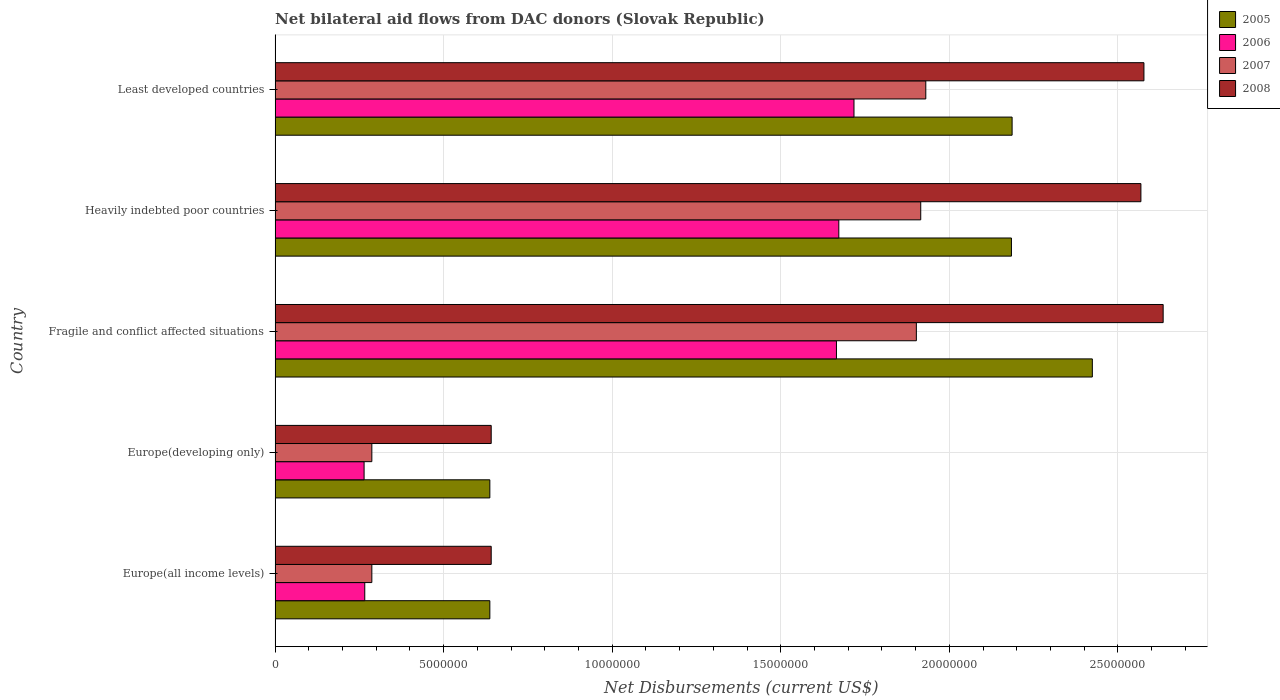Are the number of bars on each tick of the Y-axis equal?
Give a very brief answer. Yes. How many bars are there on the 4th tick from the bottom?
Provide a short and direct response. 4. What is the label of the 1st group of bars from the top?
Keep it short and to the point. Least developed countries. In how many cases, is the number of bars for a given country not equal to the number of legend labels?
Offer a terse response. 0. What is the net bilateral aid flows in 2008 in Heavily indebted poor countries?
Your answer should be very brief. 2.57e+07. Across all countries, what is the maximum net bilateral aid flows in 2007?
Offer a terse response. 1.93e+07. Across all countries, what is the minimum net bilateral aid flows in 2005?
Make the answer very short. 6.37e+06. In which country was the net bilateral aid flows in 2007 maximum?
Your answer should be compact. Least developed countries. In which country was the net bilateral aid flows in 2005 minimum?
Make the answer very short. Europe(all income levels). What is the total net bilateral aid flows in 2005 in the graph?
Provide a short and direct response. 8.07e+07. What is the difference between the net bilateral aid flows in 2005 in Europe(all income levels) and that in Least developed countries?
Make the answer very short. -1.55e+07. What is the difference between the net bilateral aid flows in 2005 in Heavily indebted poor countries and the net bilateral aid flows in 2008 in Europe(all income levels)?
Your response must be concise. 1.54e+07. What is the average net bilateral aid flows in 2008 per country?
Your answer should be very brief. 1.81e+07. What is the difference between the net bilateral aid flows in 2007 and net bilateral aid flows in 2008 in Fragile and conflict affected situations?
Give a very brief answer. -7.32e+06. What is the ratio of the net bilateral aid flows in 2005 in Europe(developing only) to that in Least developed countries?
Provide a short and direct response. 0.29. Is the difference between the net bilateral aid flows in 2007 in Europe(developing only) and Heavily indebted poor countries greater than the difference between the net bilateral aid flows in 2008 in Europe(developing only) and Heavily indebted poor countries?
Ensure brevity in your answer.  Yes. What is the difference between the highest and the lowest net bilateral aid flows in 2005?
Your answer should be very brief. 1.79e+07. What does the 3rd bar from the top in Europe(developing only) represents?
Ensure brevity in your answer.  2006. Are all the bars in the graph horizontal?
Your answer should be very brief. Yes. What is the difference between two consecutive major ticks on the X-axis?
Provide a succinct answer. 5.00e+06. Where does the legend appear in the graph?
Provide a short and direct response. Top right. How many legend labels are there?
Your answer should be compact. 4. How are the legend labels stacked?
Your answer should be compact. Vertical. What is the title of the graph?
Make the answer very short. Net bilateral aid flows from DAC donors (Slovak Republic). Does "2013" appear as one of the legend labels in the graph?
Your response must be concise. No. What is the label or title of the X-axis?
Offer a very short reply. Net Disbursements (current US$). What is the label or title of the Y-axis?
Your answer should be compact. Country. What is the Net Disbursements (current US$) of 2005 in Europe(all income levels)?
Give a very brief answer. 6.37e+06. What is the Net Disbursements (current US$) of 2006 in Europe(all income levels)?
Ensure brevity in your answer.  2.66e+06. What is the Net Disbursements (current US$) in 2007 in Europe(all income levels)?
Provide a succinct answer. 2.87e+06. What is the Net Disbursements (current US$) in 2008 in Europe(all income levels)?
Provide a short and direct response. 6.41e+06. What is the Net Disbursements (current US$) in 2005 in Europe(developing only)?
Provide a succinct answer. 6.37e+06. What is the Net Disbursements (current US$) of 2006 in Europe(developing only)?
Offer a terse response. 2.64e+06. What is the Net Disbursements (current US$) in 2007 in Europe(developing only)?
Keep it short and to the point. 2.87e+06. What is the Net Disbursements (current US$) of 2008 in Europe(developing only)?
Your response must be concise. 6.41e+06. What is the Net Disbursements (current US$) of 2005 in Fragile and conflict affected situations?
Offer a terse response. 2.42e+07. What is the Net Disbursements (current US$) in 2006 in Fragile and conflict affected situations?
Your answer should be compact. 1.66e+07. What is the Net Disbursements (current US$) of 2007 in Fragile and conflict affected situations?
Provide a succinct answer. 1.90e+07. What is the Net Disbursements (current US$) of 2008 in Fragile and conflict affected situations?
Provide a succinct answer. 2.63e+07. What is the Net Disbursements (current US$) of 2005 in Heavily indebted poor countries?
Give a very brief answer. 2.18e+07. What is the Net Disbursements (current US$) of 2006 in Heavily indebted poor countries?
Your response must be concise. 1.67e+07. What is the Net Disbursements (current US$) of 2007 in Heavily indebted poor countries?
Offer a very short reply. 1.92e+07. What is the Net Disbursements (current US$) in 2008 in Heavily indebted poor countries?
Give a very brief answer. 2.57e+07. What is the Net Disbursements (current US$) of 2005 in Least developed countries?
Make the answer very short. 2.19e+07. What is the Net Disbursements (current US$) of 2006 in Least developed countries?
Your answer should be compact. 1.72e+07. What is the Net Disbursements (current US$) of 2007 in Least developed countries?
Give a very brief answer. 1.93e+07. What is the Net Disbursements (current US$) of 2008 in Least developed countries?
Your answer should be very brief. 2.58e+07. Across all countries, what is the maximum Net Disbursements (current US$) in 2005?
Ensure brevity in your answer.  2.42e+07. Across all countries, what is the maximum Net Disbursements (current US$) in 2006?
Provide a succinct answer. 1.72e+07. Across all countries, what is the maximum Net Disbursements (current US$) in 2007?
Give a very brief answer. 1.93e+07. Across all countries, what is the maximum Net Disbursements (current US$) in 2008?
Give a very brief answer. 2.63e+07. Across all countries, what is the minimum Net Disbursements (current US$) in 2005?
Your response must be concise. 6.37e+06. Across all countries, what is the minimum Net Disbursements (current US$) of 2006?
Provide a short and direct response. 2.64e+06. Across all countries, what is the minimum Net Disbursements (current US$) in 2007?
Your response must be concise. 2.87e+06. Across all countries, what is the minimum Net Disbursements (current US$) of 2008?
Offer a very short reply. 6.41e+06. What is the total Net Disbursements (current US$) in 2005 in the graph?
Ensure brevity in your answer.  8.07e+07. What is the total Net Disbursements (current US$) in 2006 in the graph?
Keep it short and to the point. 5.58e+07. What is the total Net Disbursements (current US$) of 2007 in the graph?
Your answer should be compact. 6.32e+07. What is the total Net Disbursements (current US$) in 2008 in the graph?
Offer a terse response. 9.06e+07. What is the difference between the Net Disbursements (current US$) of 2005 in Europe(all income levels) and that in Europe(developing only)?
Give a very brief answer. 0. What is the difference between the Net Disbursements (current US$) in 2007 in Europe(all income levels) and that in Europe(developing only)?
Provide a short and direct response. 0. What is the difference between the Net Disbursements (current US$) in 2005 in Europe(all income levels) and that in Fragile and conflict affected situations?
Provide a succinct answer. -1.79e+07. What is the difference between the Net Disbursements (current US$) of 2006 in Europe(all income levels) and that in Fragile and conflict affected situations?
Your answer should be very brief. -1.40e+07. What is the difference between the Net Disbursements (current US$) of 2007 in Europe(all income levels) and that in Fragile and conflict affected situations?
Your answer should be very brief. -1.62e+07. What is the difference between the Net Disbursements (current US$) of 2008 in Europe(all income levels) and that in Fragile and conflict affected situations?
Ensure brevity in your answer.  -1.99e+07. What is the difference between the Net Disbursements (current US$) in 2005 in Europe(all income levels) and that in Heavily indebted poor countries?
Your answer should be compact. -1.55e+07. What is the difference between the Net Disbursements (current US$) in 2006 in Europe(all income levels) and that in Heavily indebted poor countries?
Make the answer very short. -1.41e+07. What is the difference between the Net Disbursements (current US$) in 2007 in Europe(all income levels) and that in Heavily indebted poor countries?
Keep it short and to the point. -1.63e+07. What is the difference between the Net Disbursements (current US$) in 2008 in Europe(all income levels) and that in Heavily indebted poor countries?
Offer a very short reply. -1.93e+07. What is the difference between the Net Disbursements (current US$) of 2005 in Europe(all income levels) and that in Least developed countries?
Keep it short and to the point. -1.55e+07. What is the difference between the Net Disbursements (current US$) of 2006 in Europe(all income levels) and that in Least developed countries?
Keep it short and to the point. -1.45e+07. What is the difference between the Net Disbursements (current US$) in 2007 in Europe(all income levels) and that in Least developed countries?
Your answer should be very brief. -1.64e+07. What is the difference between the Net Disbursements (current US$) in 2008 in Europe(all income levels) and that in Least developed countries?
Provide a succinct answer. -1.94e+07. What is the difference between the Net Disbursements (current US$) of 2005 in Europe(developing only) and that in Fragile and conflict affected situations?
Make the answer very short. -1.79e+07. What is the difference between the Net Disbursements (current US$) of 2006 in Europe(developing only) and that in Fragile and conflict affected situations?
Ensure brevity in your answer.  -1.40e+07. What is the difference between the Net Disbursements (current US$) of 2007 in Europe(developing only) and that in Fragile and conflict affected situations?
Make the answer very short. -1.62e+07. What is the difference between the Net Disbursements (current US$) of 2008 in Europe(developing only) and that in Fragile and conflict affected situations?
Provide a short and direct response. -1.99e+07. What is the difference between the Net Disbursements (current US$) of 2005 in Europe(developing only) and that in Heavily indebted poor countries?
Your answer should be very brief. -1.55e+07. What is the difference between the Net Disbursements (current US$) in 2006 in Europe(developing only) and that in Heavily indebted poor countries?
Make the answer very short. -1.41e+07. What is the difference between the Net Disbursements (current US$) of 2007 in Europe(developing only) and that in Heavily indebted poor countries?
Your response must be concise. -1.63e+07. What is the difference between the Net Disbursements (current US$) of 2008 in Europe(developing only) and that in Heavily indebted poor countries?
Give a very brief answer. -1.93e+07. What is the difference between the Net Disbursements (current US$) in 2005 in Europe(developing only) and that in Least developed countries?
Give a very brief answer. -1.55e+07. What is the difference between the Net Disbursements (current US$) in 2006 in Europe(developing only) and that in Least developed countries?
Make the answer very short. -1.45e+07. What is the difference between the Net Disbursements (current US$) of 2007 in Europe(developing only) and that in Least developed countries?
Provide a short and direct response. -1.64e+07. What is the difference between the Net Disbursements (current US$) in 2008 in Europe(developing only) and that in Least developed countries?
Ensure brevity in your answer.  -1.94e+07. What is the difference between the Net Disbursements (current US$) in 2005 in Fragile and conflict affected situations and that in Heavily indebted poor countries?
Ensure brevity in your answer.  2.40e+06. What is the difference between the Net Disbursements (current US$) in 2006 in Fragile and conflict affected situations and that in Heavily indebted poor countries?
Offer a terse response. -7.00e+04. What is the difference between the Net Disbursements (current US$) in 2007 in Fragile and conflict affected situations and that in Heavily indebted poor countries?
Your answer should be compact. -1.30e+05. What is the difference between the Net Disbursements (current US$) of 2005 in Fragile and conflict affected situations and that in Least developed countries?
Offer a very short reply. 2.38e+06. What is the difference between the Net Disbursements (current US$) of 2006 in Fragile and conflict affected situations and that in Least developed countries?
Offer a terse response. -5.20e+05. What is the difference between the Net Disbursements (current US$) of 2007 in Fragile and conflict affected situations and that in Least developed countries?
Offer a terse response. -2.80e+05. What is the difference between the Net Disbursements (current US$) of 2008 in Fragile and conflict affected situations and that in Least developed countries?
Your answer should be very brief. 5.70e+05. What is the difference between the Net Disbursements (current US$) in 2005 in Heavily indebted poor countries and that in Least developed countries?
Your answer should be very brief. -2.00e+04. What is the difference between the Net Disbursements (current US$) in 2006 in Heavily indebted poor countries and that in Least developed countries?
Your response must be concise. -4.50e+05. What is the difference between the Net Disbursements (current US$) in 2008 in Heavily indebted poor countries and that in Least developed countries?
Your response must be concise. -9.00e+04. What is the difference between the Net Disbursements (current US$) of 2005 in Europe(all income levels) and the Net Disbursements (current US$) of 2006 in Europe(developing only)?
Your answer should be very brief. 3.73e+06. What is the difference between the Net Disbursements (current US$) in 2005 in Europe(all income levels) and the Net Disbursements (current US$) in 2007 in Europe(developing only)?
Give a very brief answer. 3.50e+06. What is the difference between the Net Disbursements (current US$) in 2006 in Europe(all income levels) and the Net Disbursements (current US$) in 2008 in Europe(developing only)?
Offer a very short reply. -3.75e+06. What is the difference between the Net Disbursements (current US$) in 2007 in Europe(all income levels) and the Net Disbursements (current US$) in 2008 in Europe(developing only)?
Your answer should be very brief. -3.54e+06. What is the difference between the Net Disbursements (current US$) of 2005 in Europe(all income levels) and the Net Disbursements (current US$) of 2006 in Fragile and conflict affected situations?
Offer a terse response. -1.03e+07. What is the difference between the Net Disbursements (current US$) of 2005 in Europe(all income levels) and the Net Disbursements (current US$) of 2007 in Fragile and conflict affected situations?
Your answer should be compact. -1.26e+07. What is the difference between the Net Disbursements (current US$) in 2005 in Europe(all income levels) and the Net Disbursements (current US$) in 2008 in Fragile and conflict affected situations?
Provide a short and direct response. -2.00e+07. What is the difference between the Net Disbursements (current US$) of 2006 in Europe(all income levels) and the Net Disbursements (current US$) of 2007 in Fragile and conflict affected situations?
Your answer should be compact. -1.64e+07. What is the difference between the Net Disbursements (current US$) of 2006 in Europe(all income levels) and the Net Disbursements (current US$) of 2008 in Fragile and conflict affected situations?
Make the answer very short. -2.37e+07. What is the difference between the Net Disbursements (current US$) of 2007 in Europe(all income levels) and the Net Disbursements (current US$) of 2008 in Fragile and conflict affected situations?
Your response must be concise. -2.35e+07. What is the difference between the Net Disbursements (current US$) in 2005 in Europe(all income levels) and the Net Disbursements (current US$) in 2006 in Heavily indebted poor countries?
Your response must be concise. -1.04e+07. What is the difference between the Net Disbursements (current US$) in 2005 in Europe(all income levels) and the Net Disbursements (current US$) in 2007 in Heavily indebted poor countries?
Ensure brevity in your answer.  -1.28e+07. What is the difference between the Net Disbursements (current US$) of 2005 in Europe(all income levels) and the Net Disbursements (current US$) of 2008 in Heavily indebted poor countries?
Your response must be concise. -1.93e+07. What is the difference between the Net Disbursements (current US$) in 2006 in Europe(all income levels) and the Net Disbursements (current US$) in 2007 in Heavily indebted poor countries?
Your response must be concise. -1.65e+07. What is the difference between the Net Disbursements (current US$) in 2006 in Europe(all income levels) and the Net Disbursements (current US$) in 2008 in Heavily indebted poor countries?
Keep it short and to the point. -2.30e+07. What is the difference between the Net Disbursements (current US$) in 2007 in Europe(all income levels) and the Net Disbursements (current US$) in 2008 in Heavily indebted poor countries?
Offer a very short reply. -2.28e+07. What is the difference between the Net Disbursements (current US$) in 2005 in Europe(all income levels) and the Net Disbursements (current US$) in 2006 in Least developed countries?
Keep it short and to the point. -1.08e+07. What is the difference between the Net Disbursements (current US$) of 2005 in Europe(all income levels) and the Net Disbursements (current US$) of 2007 in Least developed countries?
Offer a terse response. -1.29e+07. What is the difference between the Net Disbursements (current US$) in 2005 in Europe(all income levels) and the Net Disbursements (current US$) in 2008 in Least developed countries?
Make the answer very short. -1.94e+07. What is the difference between the Net Disbursements (current US$) in 2006 in Europe(all income levels) and the Net Disbursements (current US$) in 2007 in Least developed countries?
Provide a short and direct response. -1.66e+07. What is the difference between the Net Disbursements (current US$) of 2006 in Europe(all income levels) and the Net Disbursements (current US$) of 2008 in Least developed countries?
Provide a succinct answer. -2.31e+07. What is the difference between the Net Disbursements (current US$) of 2007 in Europe(all income levels) and the Net Disbursements (current US$) of 2008 in Least developed countries?
Offer a terse response. -2.29e+07. What is the difference between the Net Disbursements (current US$) of 2005 in Europe(developing only) and the Net Disbursements (current US$) of 2006 in Fragile and conflict affected situations?
Your answer should be very brief. -1.03e+07. What is the difference between the Net Disbursements (current US$) of 2005 in Europe(developing only) and the Net Disbursements (current US$) of 2007 in Fragile and conflict affected situations?
Make the answer very short. -1.26e+07. What is the difference between the Net Disbursements (current US$) of 2005 in Europe(developing only) and the Net Disbursements (current US$) of 2008 in Fragile and conflict affected situations?
Give a very brief answer. -2.00e+07. What is the difference between the Net Disbursements (current US$) in 2006 in Europe(developing only) and the Net Disbursements (current US$) in 2007 in Fragile and conflict affected situations?
Give a very brief answer. -1.64e+07. What is the difference between the Net Disbursements (current US$) in 2006 in Europe(developing only) and the Net Disbursements (current US$) in 2008 in Fragile and conflict affected situations?
Give a very brief answer. -2.37e+07. What is the difference between the Net Disbursements (current US$) of 2007 in Europe(developing only) and the Net Disbursements (current US$) of 2008 in Fragile and conflict affected situations?
Provide a short and direct response. -2.35e+07. What is the difference between the Net Disbursements (current US$) of 2005 in Europe(developing only) and the Net Disbursements (current US$) of 2006 in Heavily indebted poor countries?
Offer a very short reply. -1.04e+07. What is the difference between the Net Disbursements (current US$) in 2005 in Europe(developing only) and the Net Disbursements (current US$) in 2007 in Heavily indebted poor countries?
Ensure brevity in your answer.  -1.28e+07. What is the difference between the Net Disbursements (current US$) of 2005 in Europe(developing only) and the Net Disbursements (current US$) of 2008 in Heavily indebted poor countries?
Keep it short and to the point. -1.93e+07. What is the difference between the Net Disbursements (current US$) in 2006 in Europe(developing only) and the Net Disbursements (current US$) in 2007 in Heavily indebted poor countries?
Make the answer very short. -1.65e+07. What is the difference between the Net Disbursements (current US$) in 2006 in Europe(developing only) and the Net Disbursements (current US$) in 2008 in Heavily indebted poor countries?
Keep it short and to the point. -2.30e+07. What is the difference between the Net Disbursements (current US$) in 2007 in Europe(developing only) and the Net Disbursements (current US$) in 2008 in Heavily indebted poor countries?
Your answer should be very brief. -2.28e+07. What is the difference between the Net Disbursements (current US$) of 2005 in Europe(developing only) and the Net Disbursements (current US$) of 2006 in Least developed countries?
Your answer should be compact. -1.08e+07. What is the difference between the Net Disbursements (current US$) in 2005 in Europe(developing only) and the Net Disbursements (current US$) in 2007 in Least developed countries?
Offer a terse response. -1.29e+07. What is the difference between the Net Disbursements (current US$) of 2005 in Europe(developing only) and the Net Disbursements (current US$) of 2008 in Least developed countries?
Your answer should be very brief. -1.94e+07. What is the difference between the Net Disbursements (current US$) in 2006 in Europe(developing only) and the Net Disbursements (current US$) in 2007 in Least developed countries?
Ensure brevity in your answer.  -1.67e+07. What is the difference between the Net Disbursements (current US$) in 2006 in Europe(developing only) and the Net Disbursements (current US$) in 2008 in Least developed countries?
Offer a very short reply. -2.31e+07. What is the difference between the Net Disbursements (current US$) in 2007 in Europe(developing only) and the Net Disbursements (current US$) in 2008 in Least developed countries?
Provide a short and direct response. -2.29e+07. What is the difference between the Net Disbursements (current US$) in 2005 in Fragile and conflict affected situations and the Net Disbursements (current US$) in 2006 in Heavily indebted poor countries?
Provide a short and direct response. 7.52e+06. What is the difference between the Net Disbursements (current US$) of 2005 in Fragile and conflict affected situations and the Net Disbursements (current US$) of 2007 in Heavily indebted poor countries?
Offer a very short reply. 5.09e+06. What is the difference between the Net Disbursements (current US$) of 2005 in Fragile and conflict affected situations and the Net Disbursements (current US$) of 2008 in Heavily indebted poor countries?
Give a very brief answer. -1.44e+06. What is the difference between the Net Disbursements (current US$) in 2006 in Fragile and conflict affected situations and the Net Disbursements (current US$) in 2007 in Heavily indebted poor countries?
Offer a very short reply. -2.50e+06. What is the difference between the Net Disbursements (current US$) in 2006 in Fragile and conflict affected situations and the Net Disbursements (current US$) in 2008 in Heavily indebted poor countries?
Give a very brief answer. -9.03e+06. What is the difference between the Net Disbursements (current US$) in 2007 in Fragile and conflict affected situations and the Net Disbursements (current US$) in 2008 in Heavily indebted poor countries?
Your answer should be compact. -6.66e+06. What is the difference between the Net Disbursements (current US$) in 2005 in Fragile and conflict affected situations and the Net Disbursements (current US$) in 2006 in Least developed countries?
Make the answer very short. 7.07e+06. What is the difference between the Net Disbursements (current US$) of 2005 in Fragile and conflict affected situations and the Net Disbursements (current US$) of 2007 in Least developed countries?
Your response must be concise. 4.94e+06. What is the difference between the Net Disbursements (current US$) in 2005 in Fragile and conflict affected situations and the Net Disbursements (current US$) in 2008 in Least developed countries?
Offer a very short reply. -1.53e+06. What is the difference between the Net Disbursements (current US$) of 2006 in Fragile and conflict affected situations and the Net Disbursements (current US$) of 2007 in Least developed countries?
Your response must be concise. -2.65e+06. What is the difference between the Net Disbursements (current US$) in 2006 in Fragile and conflict affected situations and the Net Disbursements (current US$) in 2008 in Least developed countries?
Offer a very short reply. -9.12e+06. What is the difference between the Net Disbursements (current US$) in 2007 in Fragile and conflict affected situations and the Net Disbursements (current US$) in 2008 in Least developed countries?
Your answer should be compact. -6.75e+06. What is the difference between the Net Disbursements (current US$) of 2005 in Heavily indebted poor countries and the Net Disbursements (current US$) of 2006 in Least developed countries?
Offer a very short reply. 4.67e+06. What is the difference between the Net Disbursements (current US$) of 2005 in Heavily indebted poor countries and the Net Disbursements (current US$) of 2007 in Least developed countries?
Your answer should be compact. 2.54e+06. What is the difference between the Net Disbursements (current US$) of 2005 in Heavily indebted poor countries and the Net Disbursements (current US$) of 2008 in Least developed countries?
Provide a short and direct response. -3.93e+06. What is the difference between the Net Disbursements (current US$) in 2006 in Heavily indebted poor countries and the Net Disbursements (current US$) in 2007 in Least developed countries?
Your response must be concise. -2.58e+06. What is the difference between the Net Disbursements (current US$) in 2006 in Heavily indebted poor countries and the Net Disbursements (current US$) in 2008 in Least developed countries?
Your response must be concise. -9.05e+06. What is the difference between the Net Disbursements (current US$) of 2007 in Heavily indebted poor countries and the Net Disbursements (current US$) of 2008 in Least developed countries?
Offer a very short reply. -6.62e+06. What is the average Net Disbursements (current US$) of 2005 per country?
Give a very brief answer. 1.61e+07. What is the average Net Disbursements (current US$) in 2006 per country?
Make the answer very short. 1.12e+07. What is the average Net Disbursements (current US$) of 2007 per country?
Your response must be concise. 1.26e+07. What is the average Net Disbursements (current US$) in 2008 per country?
Offer a very short reply. 1.81e+07. What is the difference between the Net Disbursements (current US$) in 2005 and Net Disbursements (current US$) in 2006 in Europe(all income levels)?
Your answer should be very brief. 3.71e+06. What is the difference between the Net Disbursements (current US$) of 2005 and Net Disbursements (current US$) of 2007 in Europe(all income levels)?
Ensure brevity in your answer.  3.50e+06. What is the difference between the Net Disbursements (current US$) of 2006 and Net Disbursements (current US$) of 2008 in Europe(all income levels)?
Your answer should be very brief. -3.75e+06. What is the difference between the Net Disbursements (current US$) in 2007 and Net Disbursements (current US$) in 2008 in Europe(all income levels)?
Provide a short and direct response. -3.54e+06. What is the difference between the Net Disbursements (current US$) in 2005 and Net Disbursements (current US$) in 2006 in Europe(developing only)?
Your response must be concise. 3.73e+06. What is the difference between the Net Disbursements (current US$) in 2005 and Net Disbursements (current US$) in 2007 in Europe(developing only)?
Your answer should be compact. 3.50e+06. What is the difference between the Net Disbursements (current US$) in 2006 and Net Disbursements (current US$) in 2007 in Europe(developing only)?
Your answer should be very brief. -2.30e+05. What is the difference between the Net Disbursements (current US$) in 2006 and Net Disbursements (current US$) in 2008 in Europe(developing only)?
Give a very brief answer. -3.77e+06. What is the difference between the Net Disbursements (current US$) of 2007 and Net Disbursements (current US$) of 2008 in Europe(developing only)?
Give a very brief answer. -3.54e+06. What is the difference between the Net Disbursements (current US$) of 2005 and Net Disbursements (current US$) of 2006 in Fragile and conflict affected situations?
Offer a terse response. 7.59e+06. What is the difference between the Net Disbursements (current US$) of 2005 and Net Disbursements (current US$) of 2007 in Fragile and conflict affected situations?
Your answer should be compact. 5.22e+06. What is the difference between the Net Disbursements (current US$) of 2005 and Net Disbursements (current US$) of 2008 in Fragile and conflict affected situations?
Give a very brief answer. -2.10e+06. What is the difference between the Net Disbursements (current US$) in 2006 and Net Disbursements (current US$) in 2007 in Fragile and conflict affected situations?
Your answer should be very brief. -2.37e+06. What is the difference between the Net Disbursements (current US$) of 2006 and Net Disbursements (current US$) of 2008 in Fragile and conflict affected situations?
Your response must be concise. -9.69e+06. What is the difference between the Net Disbursements (current US$) of 2007 and Net Disbursements (current US$) of 2008 in Fragile and conflict affected situations?
Provide a short and direct response. -7.32e+06. What is the difference between the Net Disbursements (current US$) in 2005 and Net Disbursements (current US$) in 2006 in Heavily indebted poor countries?
Your answer should be compact. 5.12e+06. What is the difference between the Net Disbursements (current US$) of 2005 and Net Disbursements (current US$) of 2007 in Heavily indebted poor countries?
Offer a terse response. 2.69e+06. What is the difference between the Net Disbursements (current US$) of 2005 and Net Disbursements (current US$) of 2008 in Heavily indebted poor countries?
Offer a very short reply. -3.84e+06. What is the difference between the Net Disbursements (current US$) in 2006 and Net Disbursements (current US$) in 2007 in Heavily indebted poor countries?
Your response must be concise. -2.43e+06. What is the difference between the Net Disbursements (current US$) in 2006 and Net Disbursements (current US$) in 2008 in Heavily indebted poor countries?
Your answer should be compact. -8.96e+06. What is the difference between the Net Disbursements (current US$) of 2007 and Net Disbursements (current US$) of 2008 in Heavily indebted poor countries?
Give a very brief answer. -6.53e+06. What is the difference between the Net Disbursements (current US$) of 2005 and Net Disbursements (current US$) of 2006 in Least developed countries?
Give a very brief answer. 4.69e+06. What is the difference between the Net Disbursements (current US$) of 2005 and Net Disbursements (current US$) of 2007 in Least developed countries?
Keep it short and to the point. 2.56e+06. What is the difference between the Net Disbursements (current US$) of 2005 and Net Disbursements (current US$) of 2008 in Least developed countries?
Your response must be concise. -3.91e+06. What is the difference between the Net Disbursements (current US$) in 2006 and Net Disbursements (current US$) in 2007 in Least developed countries?
Your answer should be very brief. -2.13e+06. What is the difference between the Net Disbursements (current US$) in 2006 and Net Disbursements (current US$) in 2008 in Least developed countries?
Offer a terse response. -8.60e+06. What is the difference between the Net Disbursements (current US$) in 2007 and Net Disbursements (current US$) in 2008 in Least developed countries?
Keep it short and to the point. -6.47e+06. What is the ratio of the Net Disbursements (current US$) in 2005 in Europe(all income levels) to that in Europe(developing only)?
Provide a short and direct response. 1. What is the ratio of the Net Disbursements (current US$) in 2006 in Europe(all income levels) to that in Europe(developing only)?
Provide a succinct answer. 1.01. What is the ratio of the Net Disbursements (current US$) in 2008 in Europe(all income levels) to that in Europe(developing only)?
Your answer should be compact. 1. What is the ratio of the Net Disbursements (current US$) of 2005 in Europe(all income levels) to that in Fragile and conflict affected situations?
Offer a terse response. 0.26. What is the ratio of the Net Disbursements (current US$) in 2006 in Europe(all income levels) to that in Fragile and conflict affected situations?
Ensure brevity in your answer.  0.16. What is the ratio of the Net Disbursements (current US$) of 2007 in Europe(all income levels) to that in Fragile and conflict affected situations?
Give a very brief answer. 0.15. What is the ratio of the Net Disbursements (current US$) of 2008 in Europe(all income levels) to that in Fragile and conflict affected situations?
Ensure brevity in your answer.  0.24. What is the ratio of the Net Disbursements (current US$) of 2005 in Europe(all income levels) to that in Heavily indebted poor countries?
Provide a succinct answer. 0.29. What is the ratio of the Net Disbursements (current US$) of 2006 in Europe(all income levels) to that in Heavily indebted poor countries?
Make the answer very short. 0.16. What is the ratio of the Net Disbursements (current US$) of 2007 in Europe(all income levels) to that in Heavily indebted poor countries?
Provide a succinct answer. 0.15. What is the ratio of the Net Disbursements (current US$) in 2008 in Europe(all income levels) to that in Heavily indebted poor countries?
Ensure brevity in your answer.  0.25. What is the ratio of the Net Disbursements (current US$) of 2005 in Europe(all income levels) to that in Least developed countries?
Provide a short and direct response. 0.29. What is the ratio of the Net Disbursements (current US$) of 2006 in Europe(all income levels) to that in Least developed countries?
Make the answer very short. 0.15. What is the ratio of the Net Disbursements (current US$) in 2007 in Europe(all income levels) to that in Least developed countries?
Offer a very short reply. 0.15. What is the ratio of the Net Disbursements (current US$) of 2008 in Europe(all income levels) to that in Least developed countries?
Provide a short and direct response. 0.25. What is the ratio of the Net Disbursements (current US$) of 2005 in Europe(developing only) to that in Fragile and conflict affected situations?
Provide a short and direct response. 0.26. What is the ratio of the Net Disbursements (current US$) in 2006 in Europe(developing only) to that in Fragile and conflict affected situations?
Offer a terse response. 0.16. What is the ratio of the Net Disbursements (current US$) of 2007 in Europe(developing only) to that in Fragile and conflict affected situations?
Ensure brevity in your answer.  0.15. What is the ratio of the Net Disbursements (current US$) of 2008 in Europe(developing only) to that in Fragile and conflict affected situations?
Your response must be concise. 0.24. What is the ratio of the Net Disbursements (current US$) in 2005 in Europe(developing only) to that in Heavily indebted poor countries?
Your response must be concise. 0.29. What is the ratio of the Net Disbursements (current US$) of 2006 in Europe(developing only) to that in Heavily indebted poor countries?
Offer a very short reply. 0.16. What is the ratio of the Net Disbursements (current US$) in 2007 in Europe(developing only) to that in Heavily indebted poor countries?
Keep it short and to the point. 0.15. What is the ratio of the Net Disbursements (current US$) of 2008 in Europe(developing only) to that in Heavily indebted poor countries?
Ensure brevity in your answer.  0.25. What is the ratio of the Net Disbursements (current US$) of 2005 in Europe(developing only) to that in Least developed countries?
Your answer should be very brief. 0.29. What is the ratio of the Net Disbursements (current US$) in 2006 in Europe(developing only) to that in Least developed countries?
Offer a very short reply. 0.15. What is the ratio of the Net Disbursements (current US$) of 2007 in Europe(developing only) to that in Least developed countries?
Provide a short and direct response. 0.15. What is the ratio of the Net Disbursements (current US$) in 2008 in Europe(developing only) to that in Least developed countries?
Offer a very short reply. 0.25. What is the ratio of the Net Disbursements (current US$) in 2005 in Fragile and conflict affected situations to that in Heavily indebted poor countries?
Keep it short and to the point. 1.11. What is the ratio of the Net Disbursements (current US$) in 2007 in Fragile and conflict affected situations to that in Heavily indebted poor countries?
Make the answer very short. 0.99. What is the ratio of the Net Disbursements (current US$) in 2008 in Fragile and conflict affected situations to that in Heavily indebted poor countries?
Give a very brief answer. 1.03. What is the ratio of the Net Disbursements (current US$) in 2005 in Fragile and conflict affected situations to that in Least developed countries?
Keep it short and to the point. 1.11. What is the ratio of the Net Disbursements (current US$) in 2006 in Fragile and conflict affected situations to that in Least developed countries?
Keep it short and to the point. 0.97. What is the ratio of the Net Disbursements (current US$) of 2007 in Fragile and conflict affected situations to that in Least developed countries?
Keep it short and to the point. 0.99. What is the ratio of the Net Disbursements (current US$) of 2008 in Fragile and conflict affected situations to that in Least developed countries?
Offer a very short reply. 1.02. What is the ratio of the Net Disbursements (current US$) in 2005 in Heavily indebted poor countries to that in Least developed countries?
Your response must be concise. 1. What is the ratio of the Net Disbursements (current US$) in 2006 in Heavily indebted poor countries to that in Least developed countries?
Offer a terse response. 0.97. What is the ratio of the Net Disbursements (current US$) in 2007 in Heavily indebted poor countries to that in Least developed countries?
Ensure brevity in your answer.  0.99. What is the difference between the highest and the second highest Net Disbursements (current US$) in 2005?
Your answer should be very brief. 2.38e+06. What is the difference between the highest and the second highest Net Disbursements (current US$) in 2006?
Keep it short and to the point. 4.50e+05. What is the difference between the highest and the second highest Net Disbursements (current US$) in 2008?
Give a very brief answer. 5.70e+05. What is the difference between the highest and the lowest Net Disbursements (current US$) in 2005?
Offer a very short reply. 1.79e+07. What is the difference between the highest and the lowest Net Disbursements (current US$) of 2006?
Provide a succinct answer. 1.45e+07. What is the difference between the highest and the lowest Net Disbursements (current US$) of 2007?
Your response must be concise. 1.64e+07. What is the difference between the highest and the lowest Net Disbursements (current US$) of 2008?
Ensure brevity in your answer.  1.99e+07. 